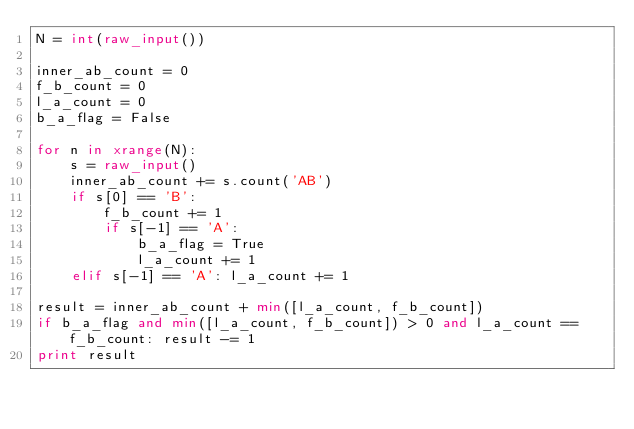<code> <loc_0><loc_0><loc_500><loc_500><_Python_>N = int(raw_input())

inner_ab_count = 0
f_b_count = 0
l_a_count = 0
b_a_flag = False

for n in xrange(N):
    s = raw_input()
    inner_ab_count += s.count('AB')
    if s[0] == 'B':
        f_b_count += 1
        if s[-1] == 'A':
            b_a_flag = True
            l_a_count += 1
    elif s[-1] == 'A': l_a_count += 1

result = inner_ab_count + min([l_a_count, f_b_count])
if b_a_flag and min([l_a_count, f_b_count]) > 0 and l_a_count == f_b_count: result -= 1
print result</code> 